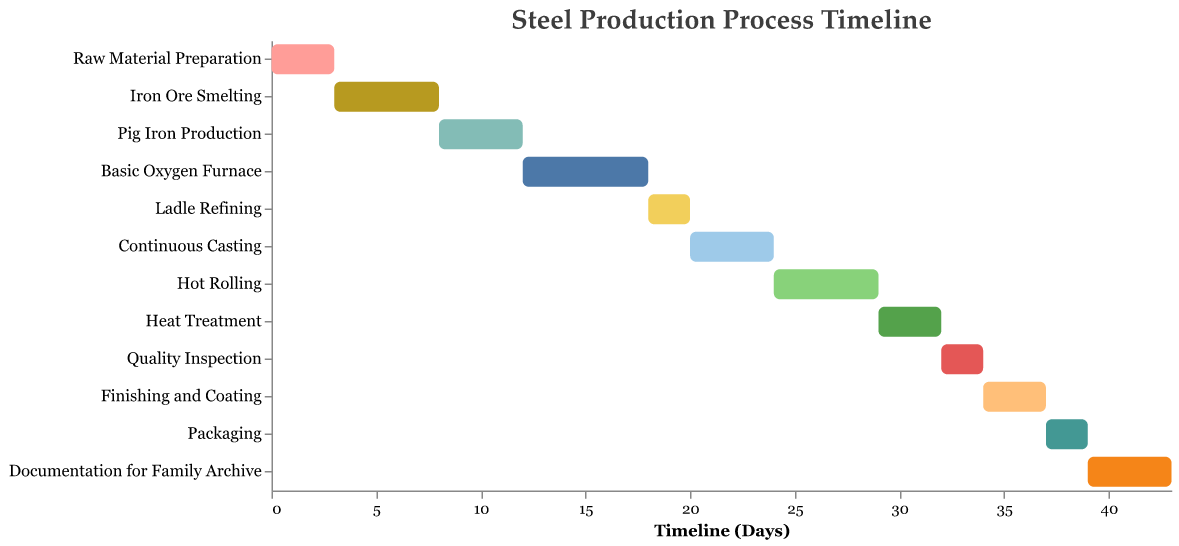What is the title of the Gantt Chart? The title of the Gantt Chart is displayed at the top of the chart and is clearly visible.
Answer: Steel Production Process Timeline How long does Hot Rolling take? Locate the task 'Hot Rolling' on the vertical axis and then check the duration indicated for this task.
Answer: 5 days Which stage starts immediately after Pig Iron Production ends? Find the end point of Pig Iron Production on the timeline and see which stage has its starting point at that same time.
Answer: Basic Oxygen Furnace What is the total duration from Raw Material Preparation to Documentation for Family Archive? Add up the duration of each task listed in the data set to determine the total duration from start to finish.
Answer: 43 days How many stages in the steel production process have a duration of 3 days? Identify the tasks from the Gantt Chart that have a bar length corresponding to 3 days.
Answer: 4 stages Which task in the steel production process occupies the longest duration? Compare the durations of each task by looking at the length of the bars on the chart to find the one with the longest bar.
Answer: Basic Oxygen Furnace If the Ladle Refining task is delayed by 1 day, how will it affect the start of Continuous Casting and subsequent stages? Adding one day to the start of Ladle Refining will push the start of Continuous Casting by one day, and we need to apply this delay to each subsequent task's start time.
Answer: Delay of 1 day for each subsequent stage Which stage in the process is scheduled to start on Day 24? Look for the task that begins at the 24th day mark on the timeline axis.
Answer: Hot Rolling Do any tasks overlap directly in the timeline? Check the chart to see if any bars overlap in both the horizontal (start and end dates) and vertical (task names) directions.
Answer: No How many stages are there in total in the steel production process according to the chart? Count the number of distinct tasks listed on the vertical axis of the Gantt Chart.
Answer: 12 stages 